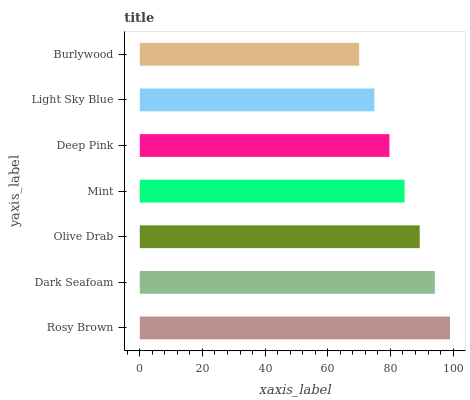Is Burlywood the minimum?
Answer yes or no. Yes. Is Rosy Brown the maximum?
Answer yes or no. Yes. Is Dark Seafoam the minimum?
Answer yes or no. No. Is Dark Seafoam the maximum?
Answer yes or no. No. Is Rosy Brown greater than Dark Seafoam?
Answer yes or no. Yes. Is Dark Seafoam less than Rosy Brown?
Answer yes or no. Yes. Is Dark Seafoam greater than Rosy Brown?
Answer yes or no. No. Is Rosy Brown less than Dark Seafoam?
Answer yes or no. No. Is Mint the high median?
Answer yes or no. Yes. Is Mint the low median?
Answer yes or no. Yes. Is Light Sky Blue the high median?
Answer yes or no. No. Is Deep Pink the low median?
Answer yes or no. No. 